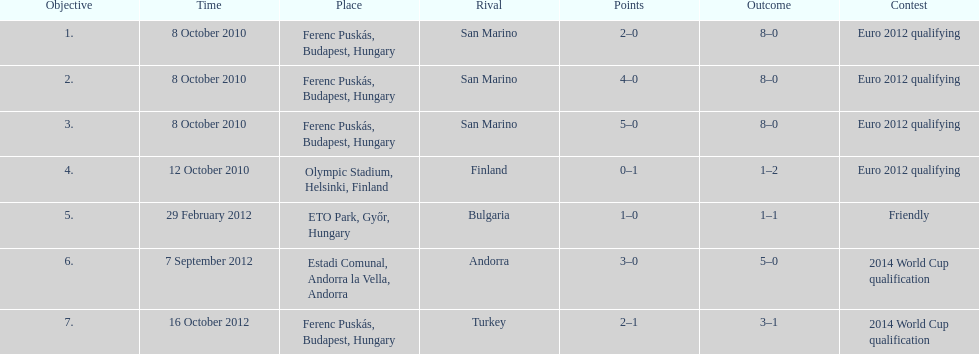In what year did ádám szalai make his next international goal after 2010? 2012. 